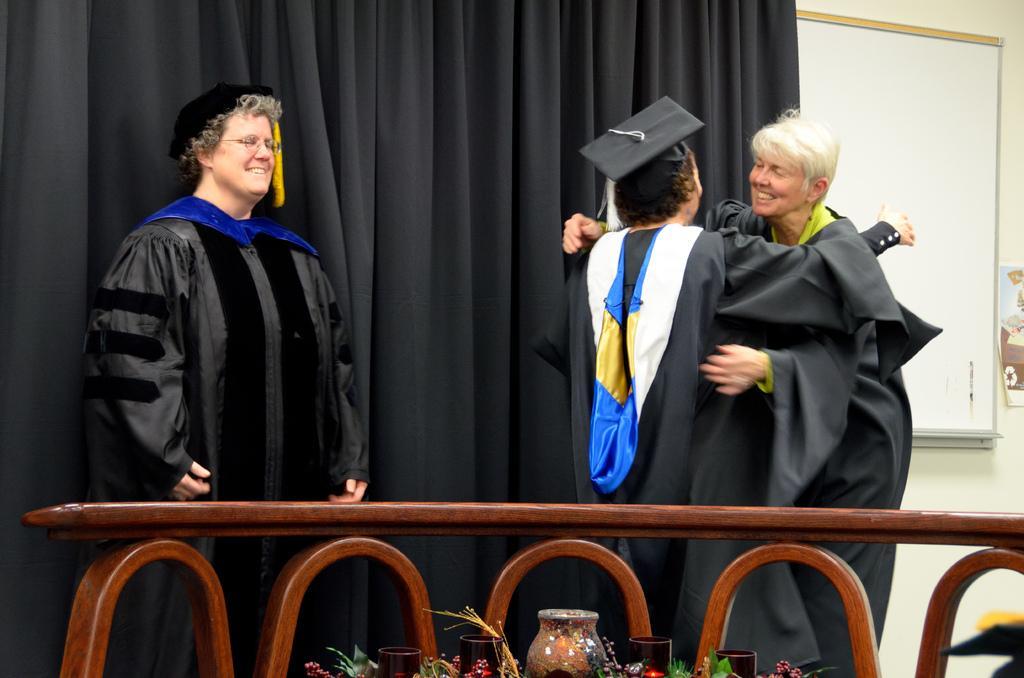Describe this image in one or two sentences. In this image we can see a three people, two of them are hugging, in front of them, there is a wooden object, there are glasses, jars, and plants, behind them there is a curtain, a board, also we can see the wall. 